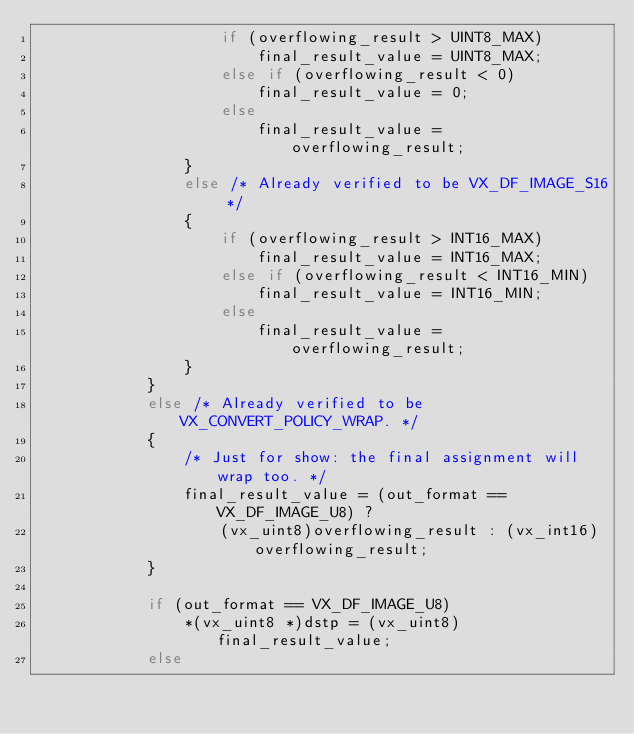<code> <loc_0><loc_0><loc_500><loc_500><_C_>                    if (overflowing_result > UINT8_MAX)
                        final_result_value = UINT8_MAX;
                    else if (overflowing_result < 0)
                        final_result_value = 0;
                    else
                        final_result_value = overflowing_result;
                }
                else /* Already verified to be VX_DF_IMAGE_S16 */
                {
                    if (overflowing_result > INT16_MAX)
                        final_result_value = INT16_MAX;
                    else if (overflowing_result < INT16_MIN)
                        final_result_value = INT16_MIN;
                    else
                        final_result_value = overflowing_result;
                }
            }
            else /* Already verified to be VX_CONVERT_POLICY_WRAP. */
            {
                /* Just for show: the final assignment will wrap too. */
                final_result_value = (out_format == VX_DF_IMAGE_U8) ?
                    (vx_uint8)overflowing_result : (vx_int16)overflowing_result;
            }

            if (out_format == VX_DF_IMAGE_U8)
                *(vx_uint8 *)dstp = (vx_uint8)final_result_value;
            else</code> 